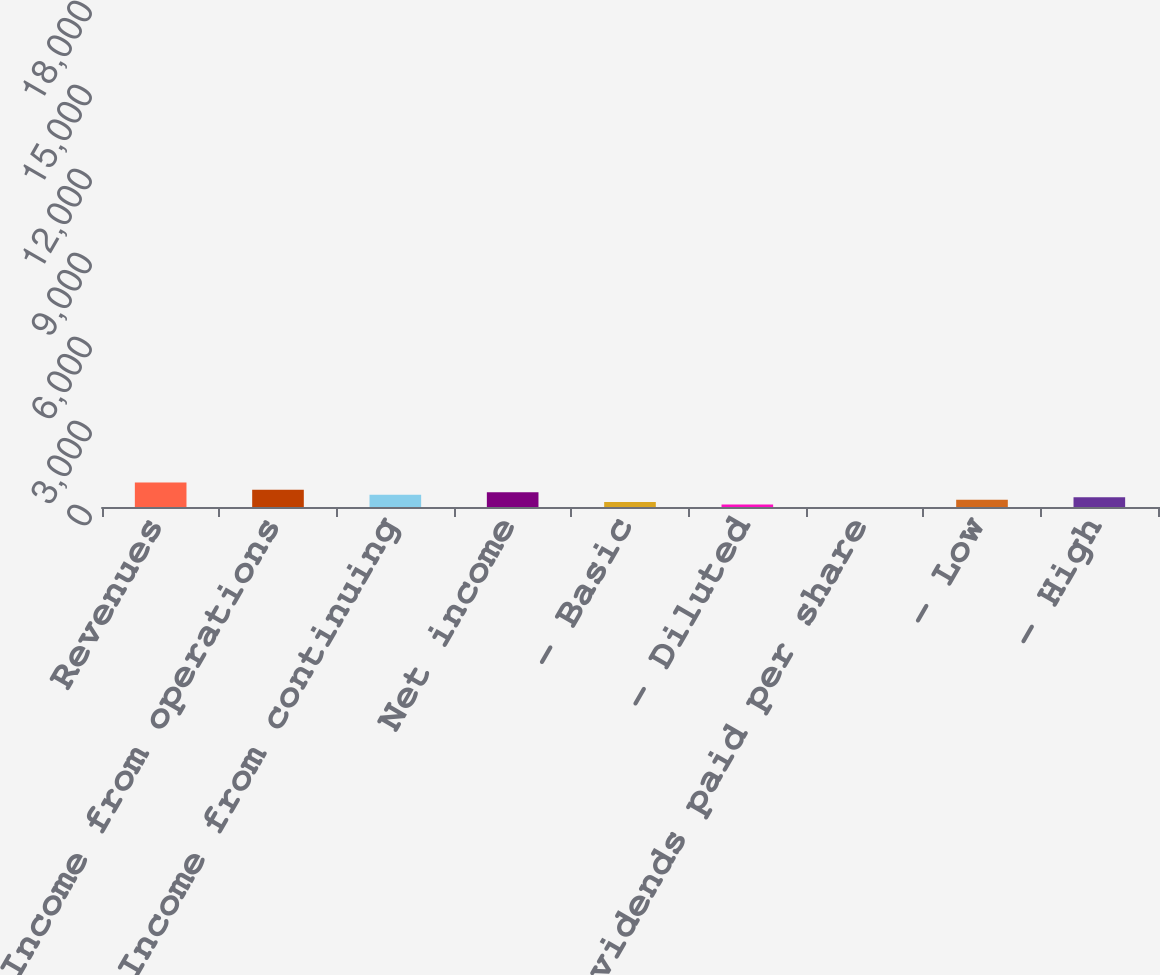Convert chart to OTSL. <chart><loc_0><loc_0><loc_500><loc_500><bar_chart><fcel>Revenues<fcel>Income from operations<fcel>Income from continuing<fcel>Net income<fcel>- Basic<fcel>- Diluted<fcel>Dividends paid per share<fcel>- Low<fcel>- High<nl><fcel>16492<fcel>11544.5<fcel>8246.1<fcel>9895.28<fcel>3298.56<fcel>1649.38<fcel>0.2<fcel>4947.74<fcel>6596.92<nl></chart> 